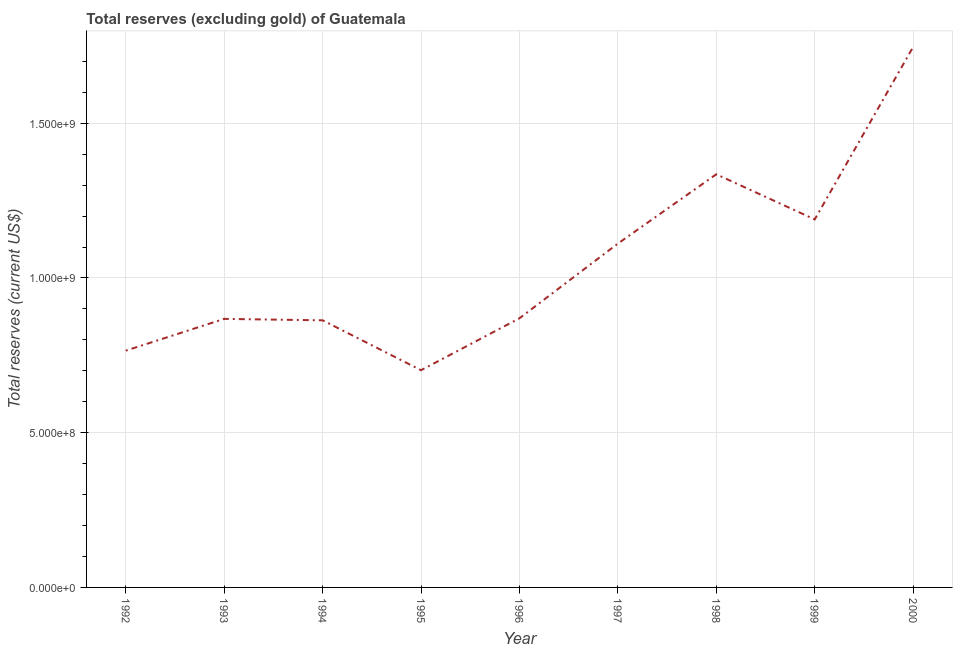What is the total reserves (excluding gold) in 2000?
Provide a succinct answer. 1.75e+09. Across all years, what is the maximum total reserves (excluding gold)?
Make the answer very short. 1.75e+09. Across all years, what is the minimum total reserves (excluding gold)?
Offer a very short reply. 7.02e+08. In which year was the total reserves (excluding gold) maximum?
Your answer should be very brief. 2000. What is the sum of the total reserves (excluding gold)?
Make the answer very short. 9.45e+09. What is the difference between the total reserves (excluding gold) in 1996 and 1998?
Keep it short and to the point. -4.65e+08. What is the average total reserves (excluding gold) per year?
Give a very brief answer. 1.05e+09. What is the median total reserves (excluding gold)?
Provide a short and direct response. 8.70e+08. What is the ratio of the total reserves (excluding gold) in 1995 to that in 1996?
Your answer should be compact. 0.81. What is the difference between the highest and the second highest total reserves (excluding gold)?
Your answer should be compact. 4.11e+08. What is the difference between the highest and the lowest total reserves (excluding gold)?
Your response must be concise. 1.04e+09. In how many years, is the total reserves (excluding gold) greater than the average total reserves (excluding gold) taken over all years?
Your answer should be very brief. 4. How many lines are there?
Keep it short and to the point. 1. Are the values on the major ticks of Y-axis written in scientific E-notation?
Your answer should be very brief. Yes. What is the title of the graph?
Provide a short and direct response. Total reserves (excluding gold) of Guatemala. What is the label or title of the Y-axis?
Your response must be concise. Total reserves (current US$). What is the Total reserves (current US$) of 1992?
Offer a very short reply. 7.65e+08. What is the Total reserves (current US$) in 1993?
Provide a succinct answer. 8.68e+08. What is the Total reserves (current US$) in 1994?
Ensure brevity in your answer.  8.63e+08. What is the Total reserves (current US$) of 1995?
Provide a succinct answer. 7.02e+08. What is the Total reserves (current US$) in 1996?
Offer a terse response. 8.70e+08. What is the Total reserves (current US$) in 1997?
Provide a short and direct response. 1.11e+09. What is the Total reserves (current US$) in 1998?
Keep it short and to the point. 1.34e+09. What is the Total reserves (current US$) of 1999?
Ensure brevity in your answer.  1.19e+09. What is the Total reserves (current US$) in 2000?
Your answer should be compact. 1.75e+09. What is the difference between the Total reserves (current US$) in 1992 and 1993?
Give a very brief answer. -1.03e+08. What is the difference between the Total reserves (current US$) in 1992 and 1994?
Keep it short and to the point. -9.79e+07. What is the difference between the Total reserves (current US$) in 1992 and 1995?
Offer a terse response. 6.33e+07. What is the difference between the Total reserves (current US$) in 1992 and 1996?
Your answer should be very brief. -1.04e+08. What is the difference between the Total reserves (current US$) in 1992 and 1997?
Offer a terse response. -3.46e+08. What is the difference between the Total reserves (current US$) in 1992 and 1998?
Make the answer very short. -5.70e+08. What is the difference between the Total reserves (current US$) in 1992 and 1999?
Your answer should be very brief. -4.24e+08. What is the difference between the Total reserves (current US$) in 1992 and 2000?
Provide a succinct answer. -9.81e+08. What is the difference between the Total reserves (current US$) in 1993 and 1994?
Your answer should be very brief. 4.68e+06. What is the difference between the Total reserves (current US$) in 1993 and 1995?
Make the answer very short. 1.66e+08. What is the difference between the Total reserves (current US$) in 1993 and 1996?
Your answer should be very brief. -1.90e+06. What is the difference between the Total reserves (current US$) in 1993 and 1997?
Make the answer very short. -2.43e+08. What is the difference between the Total reserves (current US$) in 1993 and 1998?
Keep it short and to the point. -4.67e+08. What is the difference between the Total reserves (current US$) in 1993 and 1999?
Your answer should be compact. -3.21e+08. What is the difference between the Total reserves (current US$) in 1993 and 2000?
Provide a succinct answer. -8.79e+08. What is the difference between the Total reserves (current US$) in 1994 and 1995?
Provide a short and direct response. 1.61e+08. What is the difference between the Total reserves (current US$) in 1994 and 1996?
Your answer should be compact. -6.58e+06. What is the difference between the Total reserves (current US$) in 1994 and 1997?
Ensure brevity in your answer.  -2.48e+08. What is the difference between the Total reserves (current US$) in 1994 and 1998?
Provide a short and direct response. -4.72e+08. What is the difference between the Total reserves (current US$) in 1994 and 1999?
Your answer should be compact. -3.26e+08. What is the difference between the Total reserves (current US$) in 1994 and 2000?
Keep it short and to the point. -8.83e+08. What is the difference between the Total reserves (current US$) in 1995 and 1996?
Keep it short and to the point. -1.68e+08. What is the difference between the Total reserves (current US$) in 1995 and 1997?
Offer a terse response. -4.09e+08. What is the difference between the Total reserves (current US$) in 1995 and 1998?
Offer a terse response. -6.33e+08. What is the difference between the Total reserves (current US$) in 1995 and 1999?
Offer a terse response. -4.87e+08. What is the difference between the Total reserves (current US$) in 1995 and 2000?
Provide a short and direct response. -1.04e+09. What is the difference between the Total reserves (current US$) in 1996 and 1997?
Ensure brevity in your answer.  -2.41e+08. What is the difference between the Total reserves (current US$) in 1996 and 1998?
Your answer should be very brief. -4.65e+08. What is the difference between the Total reserves (current US$) in 1996 and 1999?
Your answer should be very brief. -3.19e+08. What is the difference between the Total reserves (current US$) in 1996 and 2000?
Give a very brief answer. -8.77e+08. What is the difference between the Total reserves (current US$) in 1997 and 1998?
Offer a very short reply. -2.24e+08. What is the difference between the Total reserves (current US$) in 1997 and 1999?
Give a very brief answer. -7.80e+07. What is the difference between the Total reserves (current US$) in 1997 and 2000?
Ensure brevity in your answer.  -6.35e+08. What is the difference between the Total reserves (current US$) in 1998 and 1999?
Your response must be concise. 1.46e+08. What is the difference between the Total reserves (current US$) in 1998 and 2000?
Keep it short and to the point. -4.11e+08. What is the difference between the Total reserves (current US$) in 1999 and 2000?
Make the answer very short. -5.57e+08. What is the ratio of the Total reserves (current US$) in 1992 to that in 1993?
Your answer should be very brief. 0.88. What is the ratio of the Total reserves (current US$) in 1992 to that in 1994?
Your response must be concise. 0.89. What is the ratio of the Total reserves (current US$) in 1992 to that in 1995?
Make the answer very short. 1.09. What is the ratio of the Total reserves (current US$) in 1992 to that in 1996?
Your answer should be compact. 0.88. What is the ratio of the Total reserves (current US$) in 1992 to that in 1997?
Provide a short and direct response. 0.69. What is the ratio of the Total reserves (current US$) in 1992 to that in 1998?
Offer a terse response. 0.57. What is the ratio of the Total reserves (current US$) in 1992 to that in 1999?
Keep it short and to the point. 0.64. What is the ratio of the Total reserves (current US$) in 1992 to that in 2000?
Your answer should be very brief. 0.44. What is the ratio of the Total reserves (current US$) in 1993 to that in 1994?
Keep it short and to the point. 1. What is the ratio of the Total reserves (current US$) in 1993 to that in 1995?
Your answer should be very brief. 1.24. What is the ratio of the Total reserves (current US$) in 1993 to that in 1997?
Offer a very short reply. 0.78. What is the ratio of the Total reserves (current US$) in 1993 to that in 1998?
Make the answer very short. 0.65. What is the ratio of the Total reserves (current US$) in 1993 to that in 1999?
Ensure brevity in your answer.  0.73. What is the ratio of the Total reserves (current US$) in 1993 to that in 2000?
Keep it short and to the point. 0.5. What is the ratio of the Total reserves (current US$) in 1994 to that in 1995?
Provide a short and direct response. 1.23. What is the ratio of the Total reserves (current US$) in 1994 to that in 1996?
Keep it short and to the point. 0.99. What is the ratio of the Total reserves (current US$) in 1994 to that in 1997?
Your response must be concise. 0.78. What is the ratio of the Total reserves (current US$) in 1994 to that in 1998?
Keep it short and to the point. 0.65. What is the ratio of the Total reserves (current US$) in 1994 to that in 1999?
Give a very brief answer. 0.73. What is the ratio of the Total reserves (current US$) in 1994 to that in 2000?
Your answer should be compact. 0.49. What is the ratio of the Total reserves (current US$) in 1995 to that in 1996?
Your answer should be compact. 0.81. What is the ratio of the Total reserves (current US$) in 1995 to that in 1997?
Ensure brevity in your answer.  0.63. What is the ratio of the Total reserves (current US$) in 1995 to that in 1998?
Give a very brief answer. 0.53. What is the ratio of the Total reserves (current US$) in 1995 to that in 1999?
Keep it short and to the point. 0.59. What is the ratio of the Total reserves (current US$) in 1995 to that in 2000?
Offer a terse response. 0.4. What is the ratio of the Total reserves (current US$) in 1996 to that in 1997?
Provide a short and direct response. 0.78. What is the ratio of the Total reserves (current US$) in 1996 to that in 1998?
Your answer should be compact. 0.65. What is the ratio of the Total reserves (current US$) in 1996 to that in 1999?
Provide a short and direct response. 0.73. What is the ratio of the Total reserves (current US$) in 1996 to that in 2000?
Offer a very short reply. 0.5. What is the ratio of the Total reserves (current US$) in 1997 to that in 1998?
Provide a succinct answer. 0.83. What is the ratio of the Total reserves (current US$) in 1997 to that in 1999?
Ensure brevity in your answer.  0.93. What is the ratio of the Total reserves (current US$) in 1997 to that in 2000?
Offer a very short reply. 0.64. What is the ratio of the Total reserves (current US$) in 1998 to that in 1999?
Make the answer very short. 1.12. What is the ratio of the Total reserves (current US$) in 1998 to that in 2000?
Your response must be concise. 0.76. What is the ratio of the Total reserves (current US$) in 1999 to that in 2000?
Give a very brief answer. 0.68. 